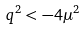<formula> <loc_0><loc_0><loc_500><loc_500>q ^ { 2 } < - 4 \mu ^ { 2 }</formula> 